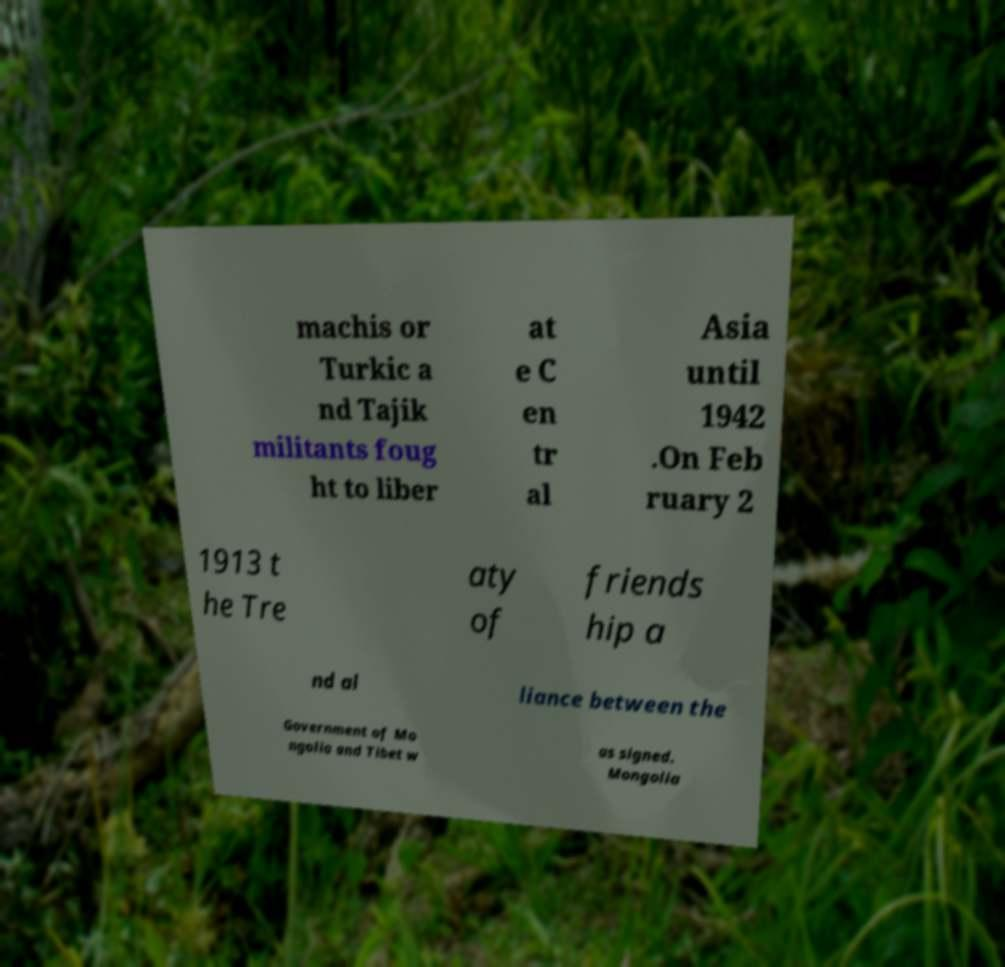Can you accurately transcribe the text from the provided image for me? machis or Turkic a nd Tajik militants foug ht to liber at e C en tr al Asia until 1942 .On Feb ruary 2 1913 t he Tre aty of friends hip a nd al liance between the Government of Mo ngolia and Tibet w as signed. Mongolia 